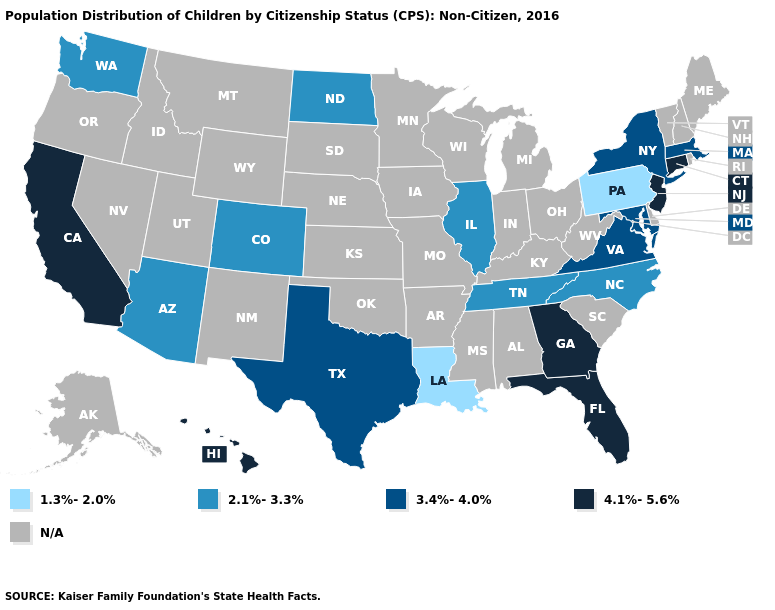Name the states that have a value in the range N/A?
Concise answer only. Alabama, Alaska, Arkansas, Delaware, Idaho, Indiana, Iowa, Kansas, Kentucky, Maine, Michigan, Minnesota, Mississippi, Missouri, Montana, Nebraska, Nevada, New Hampshire, New Mexico, Ohio, Oklahoma, Oregon, Rhode Island, South Carolina, South Dakota, Utah, Vermont, West Virginia, Wisconsin, Wyoming. Name the states that have a value in the range 2.1%-3.3%?
Concise answer only. Arizona, Colorado, Illinois, North Carolina, North Dakota, Tennessee, Washington. Name the states that have a value in the range 1.3%-2.0%?
Give a very brief answer. Louisiana, Pennsylvania. What is the lowest value in states that border Arkansas?
Answer briefly. 1.3%-2.0%. Name the states that have a value in the range 1.3%-2.0%?
Answer briefly. Louisiana, Pennsylvania. Does the first symbol in the legend represent the smallest category?
Write a very short answer. Yes. What is the value of Maryland?
Concise answer only. 3.4%-4.0%. What is the lowest value in states that border Colorado?
Keep it brief. 2.1%-3.3%. Does New York have the highest value in the Northeast?
Write a very short answer. No. Name the states that have a value in the range 1.3%-2.0%?
Concise answer only. Louisiana, Pennsylvania. What is the highest value in states that border New Jersey?
Quick response, please. 3.4%-4.0%. What is the value of Idaho?
Quick response, please. N/A. Which states have the lowest value in the USA?
Give a very brief answer. Louisiana, Pennsylvania. 